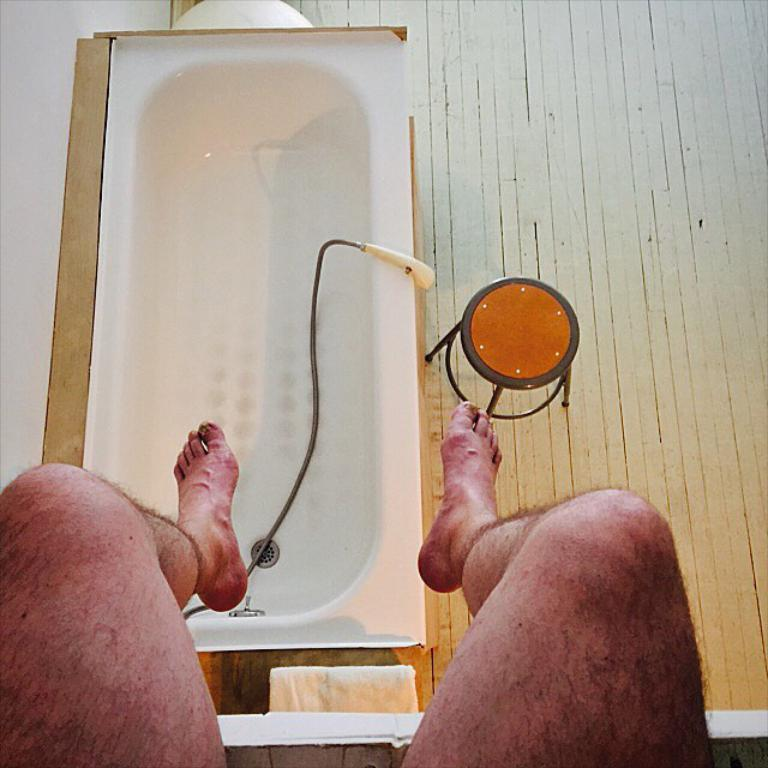What can be seen in the foreground of the picture? There are legs of persons in the foreground of the picture. What is the main object in the image? There is a bathtub in the image. What other objects are present in the image? There is a heater, a stool, and a towel in the image. What is the color of the wall on the left side of the image? The wall on the left side of the image is painted white. Can you tell me how many steps are visible in the image? There are no steps visible in the image; it features a bathtub, a heater, a stool, and a towel. Is there a cave in the image? No, there is no cave present in the image. 